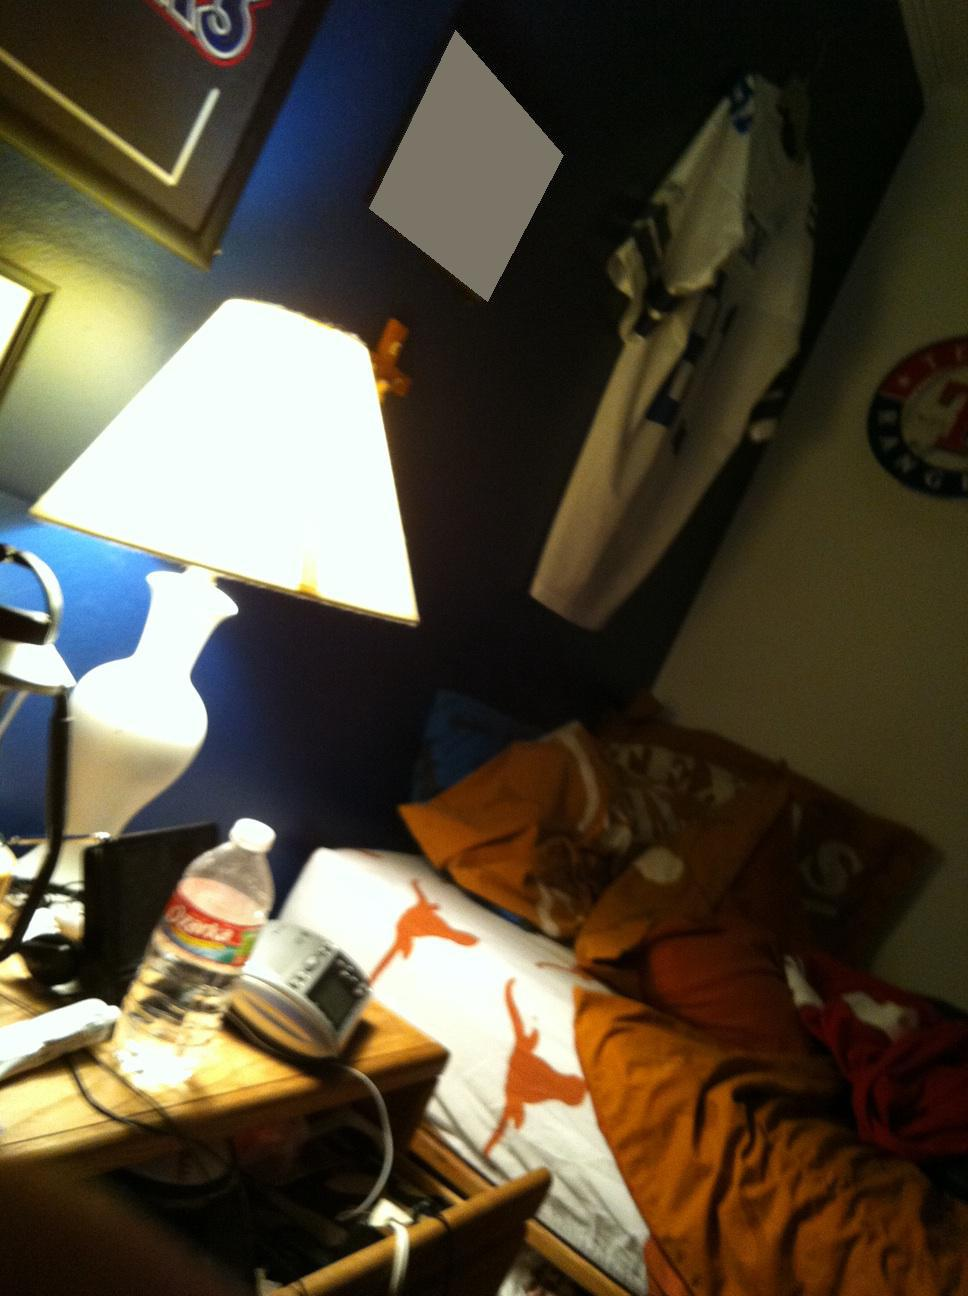Describe the lighting condition in the room? The lighting condition in the room is primarily dominated by the bright light coming from the lamp. The rest of the room appears to be in shadow or dimly lit, creating a focused illumination around the desk area. Does the lighting affect the mood of the room? Yes, the concentrated light from the lamp creates a cozy and intimate atmosphere, likely making it a comfortable spot for reading, studying, or doing work. 